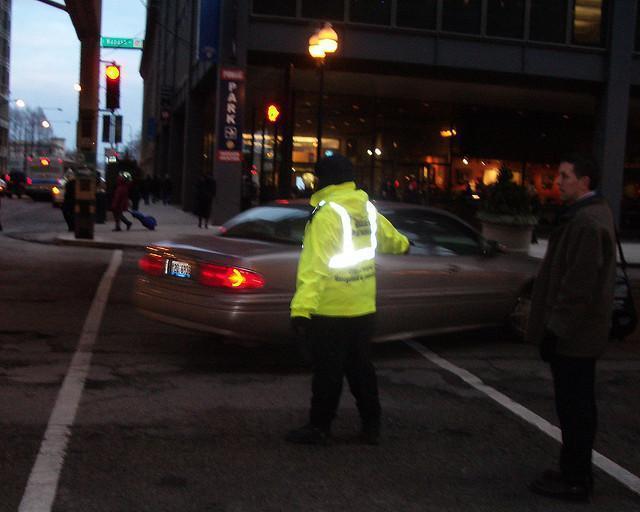Why is the man wearing a reflective jacket?
Select the correct answer and articulate reasoning with the following format: 'Answer: answer
Rationale: rationale.'
Options: Visibility, on team, fashion, received free. Answer: visibility.
Rationale: The yellow jacket allows people to see him at night so he can be near traffic. 